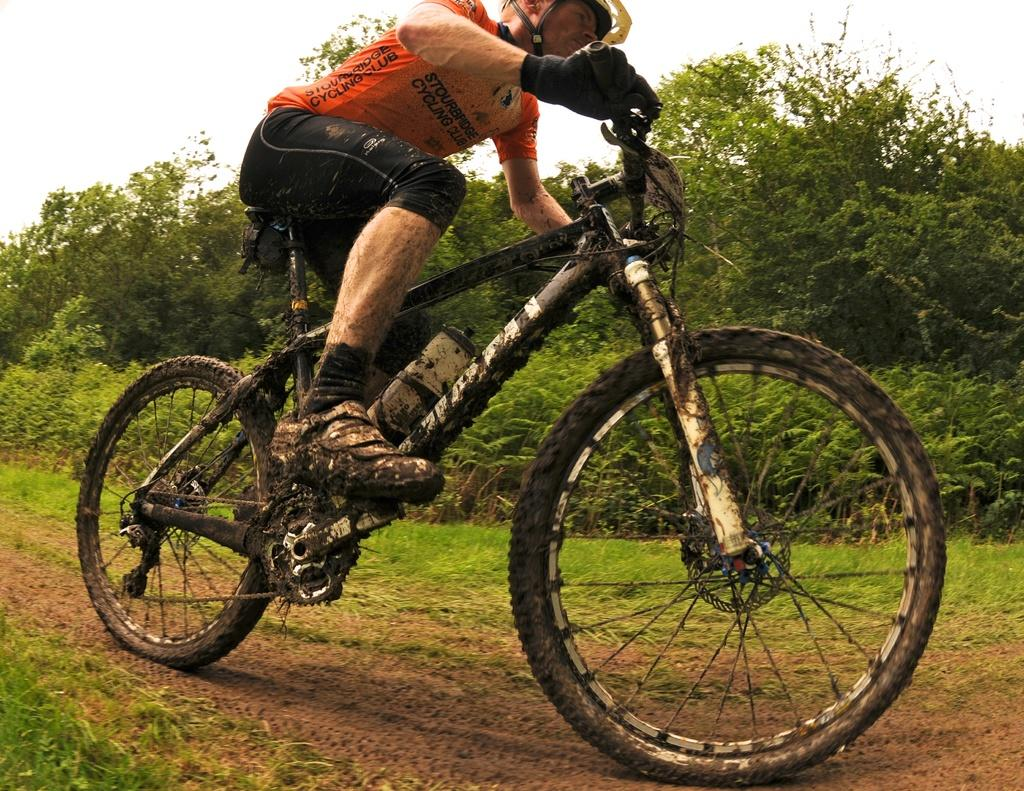<image>
Share a concise interpretation of the image provided. Person wearing an orange shirt which says "Stourbridge Cycling Club" riding a dirty bike. 